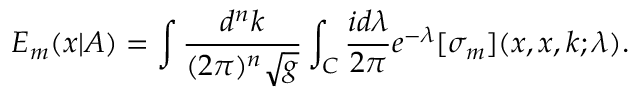<formula> <loc_0><loc_0><loc_500><loc_500>E _ { m } ( x | A ) = \int \frac { d ^ { n } k } { ( 2 \pi ) ^ { n } \sqrt { g } } \int _ { C } \frac { i d \lambda } { 2 \pi } e ^ { - \lambda } [ \sigma _ { m } ] ( x , x , k ; \lambda ) .</formula> 